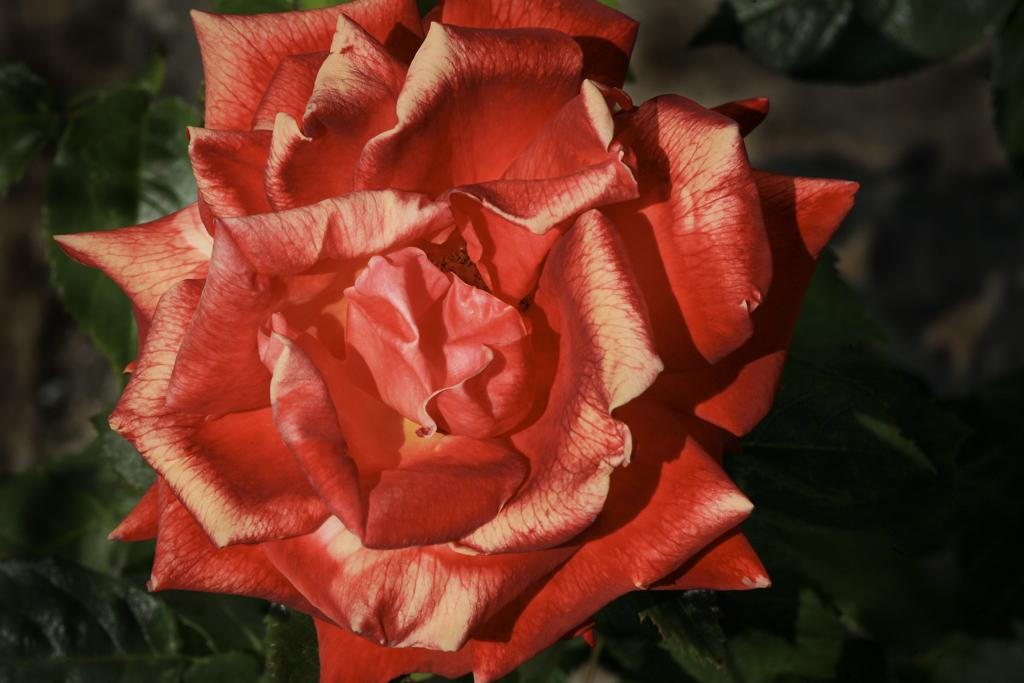Where was the image most likely taken? The image was likely taken outside. What is the main subject of the image? There is a flower in the center of the image. What color are the leaves visible in the image? There are green leaves visible in the image. What type of vegetation can be seen in the image? There are plants in the image. What type of bead is used to decorate the school in the image? There is no school or bead present in the image; it features a flower and green leaves. 